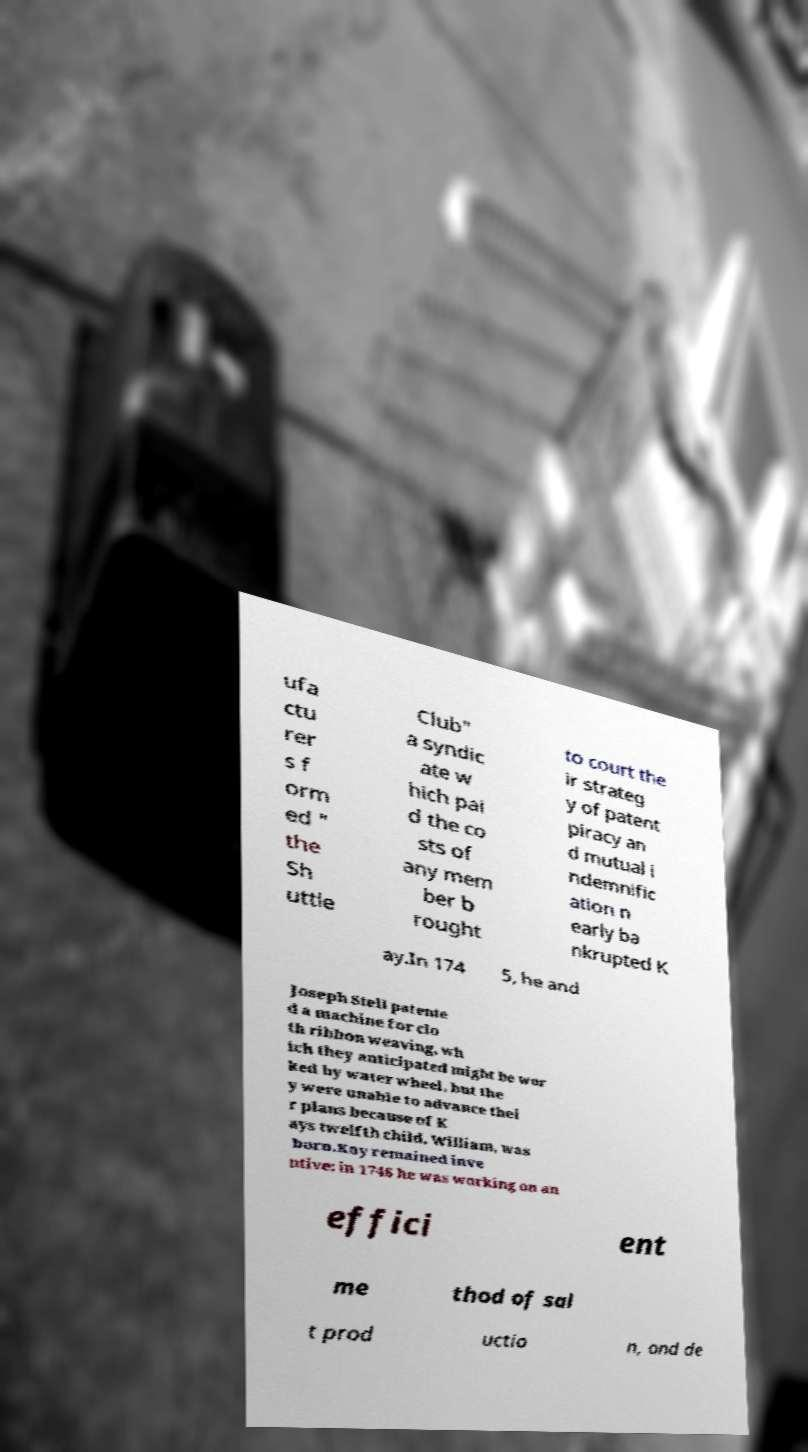What messages or text are displayed in this image? I need them in a readable, typed format. ufa ctu rer s f orm ed " the Sh uttle Club" a syndic ate w hich pai d the co sts of any mem ber b rought to court the ir strateg y of patent piracy an d mutual i ndemnific ation n early ba nkrupted K ay.In 174 5, he and Joseph Stell patente d a machine for clo th ribbon weaving, wh ich they anticipated might be wor ked by water wheel, but the y were unable to advance thei r plans because of K ays twelfth child, William, was born.Kay remained inve ntive; in 1746 he was working on an effici ent me thod of sal t prod uctio n, and de 